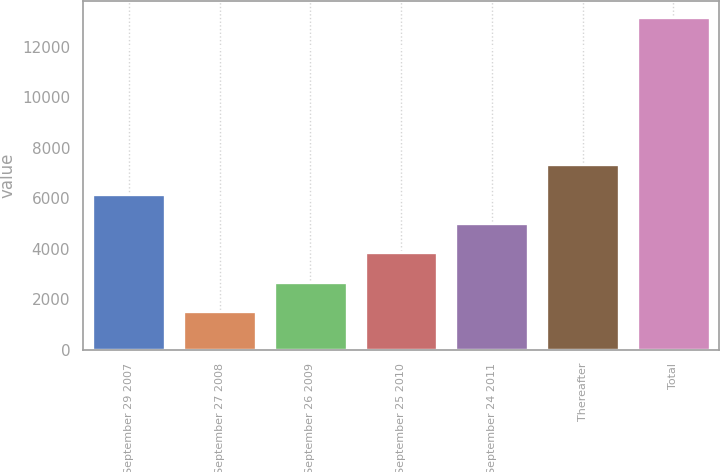Convert chart. <chart><loc_0><loc_0><loc_500><loc_500><bar_chart><fcel>September 29 2007<fcel>September 27 2008<fcel>September 26 2009<fcel>September 25 2010<fcel>September 24 2011<fcel>Thereafter<fcel>Total<nl><fcel>6181.4<fcel>1531<fcel>2693.6<fcel>3856.2<fcel>5018.8<fcel>7344<fcel>13157<nl></chart> 